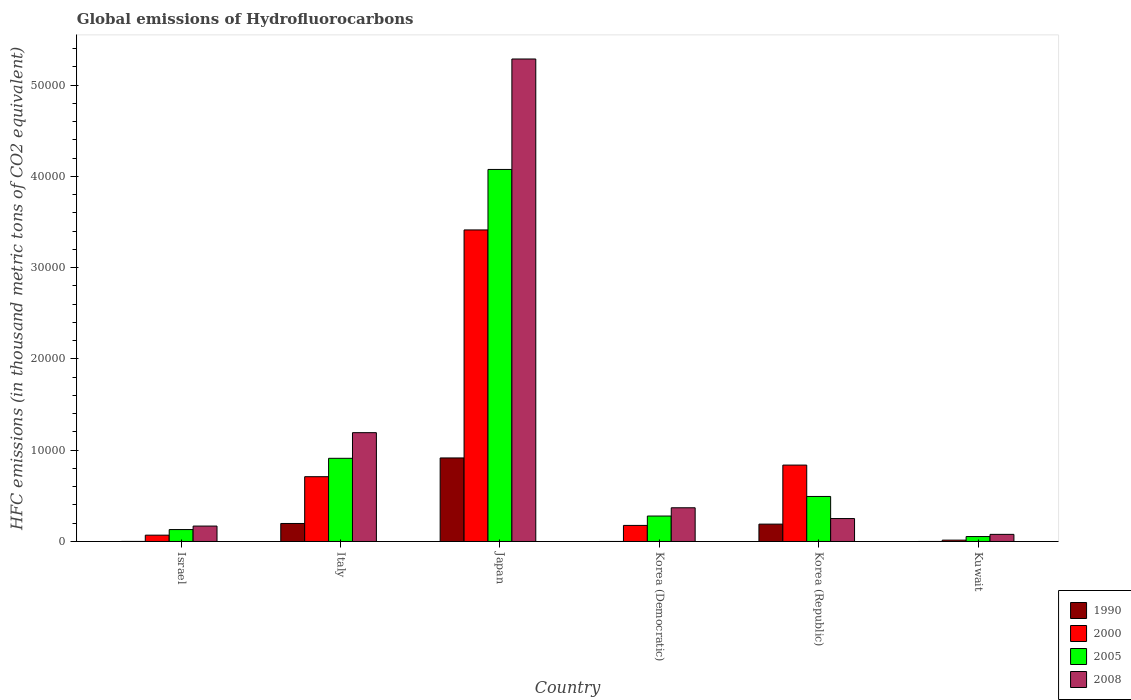Are the number of bars per tick equal to the number of legend labels?
Keep it short and to the point. Yes. How many bars are there on the 2nd tick from the left?
Make the answer very short. 4. In how many cases, is the number of bars for a given country not equal to the number of legend labels?
Make the answer very short. 0. What is the global emissions of Hydrofluorocarbons in 2000 in Japan?
Make the answer very short. 3.41e+04. Across all countries, what is the maximum global emissions of Hydrofluorocarbons in 1990?
Offer a terse response. 9154.3. Across all countries, what is the minimum global emissions of Hydrofluorocarbons in 2000?
Ensure brevity in your answer.  147.3. In which country was the global emissions of Hydrofluorocarbons in 2000 maximum?
Your answer should be compact. Japan. In which country was the global emissions of Hydrofluorocarbons in 2000 minimum?
Ensure brevity in your answer.  Kuwait. What is the total global emissions of Hydrofluorocarbons in 1990 in the graph?
Offer a very short reply. 1.30e+04. What is the difference between the global emissions of Hydrofluorocarbons in 2005 in Israel and that in Italy?
Keep it short and to the point. -7809.5. What is the difference between the global emissions of Hydrofluorocarbons in 1990 in Japan and the global emissions of Hydrofluorocarbons in 2008 in Italy?
Your response must be concise. -2770.2. What is the average global emissions of Hydrofluorocarbons in 2008 per country?
Provide a succinct answer. 1.22e+04. What is the difference between the global emissions of Hydrofluorocarbons of/in 2000 and global emissions of Hydrofluorocarbons of/in 2005 in Italy?
Offer a very short reply. -2015. In how many countries, is the global emissions of Hydrofluorocarbons in 1990 greater than 10000 thousand metric tons?
Make the answer very short. 0. What is the ratio of the global emissions of Hydrofluorocarbons in 1990 in Israel to that in Italy?
Keep it short and to the point. 0. What is the difference between the highest and the second highest global emissions of Hydrofluorocarbons in 2005?
Provide a short and direct response. 3.17e+04. What is the difference between the highest and the lowest global emissions of Hydrofluorocarbons in 2000?
Ensure brevity in your answer.  3.40e+04. In how many countries, is the global emissions of Hydrofluorocarbons in 2000 greater than the average global emissions of Hydrofluorocarbons in 2000 taken over all countries?
Give a very brief answer. 1. Is it the case that in every country, the sum of the global emissions of Hydrofluorocarbons in 2005 and global emissions of Hydrofluorocarbons in 1990 is greater than the sum of global emissions of Hydrofluorocarbons in 2008 and global emissions of Hydrofluorocarbons in 2000?
Ensure brevity in your answer.  No. How many bars are there?
Offer a terse response. 24. Are all the bars in the graph horizontal?
Offer a very short reply. No. How many countries are there in the graph?
Give a very brief answer. 6. What is the difference between two consecutive major ticks on the Y-axis?
Your response must be concise. 10000. Are the values on the major ticks of Y-axis written in scientific E-notation?
Give a very brief answer. No. Does the graph contain any zero values?
Your response must be concise. No. Where does the legend appear in the graph?
Your answer should be very brief. Bottom right. How are the legend labels stacked?
Keep it short and to the point. Vertical. What is the title of the graph?
Ensure brevity in your answer.  Global emissions of Hydrofluorocarbons. Does "1994" appear as one of the legend labels in the graph?
Offer a very short reply. No. What is the label or title of the Y-axis?
Provide a succinct answer. HFC emissions (in thousand metric tons of CO2 equivalent). What is the HFC emissions (in thousand metric tons of CO2 equivalent) of 2000 in Israel?
Your answer should be compact. 691.9. What is the HFC emissions (in thousand metric tons of CO2 equivalent) in 2005 in Israel?
Give a very brief answer. 1305. What is the HFC emissions (in thousand metric tons of CO2 equivalent) of 2008 in Israel?
Your response must be concise. 1687.8. What is the HFC emissions (in thousand metric tons of CO2 equivalent) in 1990 in Italy?
Offer a very short reply. 1972.2. What is the HFC emissions (in thousand metric tons of CO2 equivalent) of 2000 in Italy?
Your answer should be very brief. 7099.5. What is the HFC emissions (in thousand metric tons of CO2 equivalent) of 2005 in Italy?
Your answer should be very brief. 9114.5. What is the HFC emissions (in thousand metric tons of CO2 equivalent) of 2008 in Italy?
Provide a succinct answer. 1.19e+04. What is the HFC emissions (in thousand metric tons of CO2 equivalent) of 1990 in Japan?
Give a very brief answer. 9154.3. What is the HFC emissions (in thousand metric tons of CO2 equivalent) of 2000 in Japan?
Your answer should be compact. 3.41e+04. What is the HFC emissions (in thousand metric tons of CO2 equivalent) in 2005 in Japan?
Your answer should be very brief. 4.08e+04. What is the HFC emissions (in thousand metric tons of CO2 equivalent) of 2008 in Japan?
Give a very brief answer. 5.29e+04. What is the HFC emissions (in thousand metric tons of CO2 equivalent) in 2000 in Korea (Democratic)?
Offer a very short reply. 1760.1. What is the HFC emissions (in thousand metric tons of CO2 equivalent) in 2005 in Korea (Democratic)?
Provide a succinct answer. 2787.1. What is the HFC emissions (in thousand metric tons of CO2 equivalent) in 2008 in Korea (Democratic)?
Your response must be concise. 3693.8. What is the HFC emissions (in thousand metric tons of CO2 equivalent) of 1990 in Korea (Republic)?
Keep it short and to the point. 1901.7. What is the HFC emissions (in thousand metric tons of CO2 equivalent) in 2000 in Korea (Republic)?
Keep it short and to the point. 8371.9. What is the HFC emissions (in thousand metric tons of CO2 equivalent) in 2005 in Korea (Republic)?
Keep it short and to the point. 4933.9. What is the HFC emissions (in thousand metric tons of CO2 equivalent) in 2008 in Korea (Republic)?
Offer a terse response. 2511.2. What is the HFC emissions (in thousand metric tons of CO2 equivalent) of 2000 in Kuwait?
Provide a short and direct response. 147.3. What is the HFC emissions (in thousand metric tons of CO2 equivalent) of 2005 in Kuwait?
Offer a very short reply. 539.6. What is the HFC emissions (in thousand metric tons of CO2 equivalent) of 2008 in Kuwait?
Your response must be concise. 779. Across all countries, what is the maximum HFC emissions (in thousand metric tons of CO2 equivalent) in 1990?
Provide a short and direct response. 9154.3. Across all countries, what is the maximum HFC emissions (in thousand metric tons of CO2 equivalent) of 2000?
Your answer should be compact. 3.41e+04. Across all countries, what is the maximum HFC emissions (in thousand metric tons of CO2 equivalent) of 2005?
Provide a short and direct response. 4.08e+04. Across all countries, what is the maximum HFC emissions (in thousand metric tons of CO2 equivalent) in 2008?
Keep it short and to the point. 5.29e+04. Across all countries, what is the minimum HFC emissions (in thousand metric tons of CO2 equivalent) of 1990?
Provide a succinct answer. 0.1. Across all countries, what is the minimum HFC emissions (in thousand metric tons of CO2 equivalent) of 2000?
Offer a terse response. 147.3. Across all countries, what is the minimum HFC emissions (in thousand metric tons of CO2 equivalent) of 2005?
Make the answer very short. 539.6. Across all countries, what is the minimum HFC emissions (in thousand metric tons of CO2 equivalent) in 2008?
Offer a very short reply. 779. What is the total HFC emissions (in thousand metric tons of CO2 equivalent) in 1990 in the graph?
Provide a succinct answer. 1.30e+04. What is the total HFC emissions (in thousand metric tons of CO2 equivalent) in 2000 in the graph?
Offer a terse response. 5.22e+04. What is the total HFC emissions (in thousand metric tons of CO2 equivalent) in 2005 in the graph?
Your answer should be compact. 5.94e+04. What is the total HFC emissions (in thousand metric tons of CO2 equivalent) in 2008 in the graph?
Your answer should be very brief. 7.35e+04. What is the difference between the HFC emissions (in thousand metric tons of CO2 equivalent) of 1990 in Israel and that in Italy?
Offer a very short reply. -1967.6. What is the difference between the HFC emissions (in thousand metric tons of CO2 equivalent) in 2000 in Israel and that in Italy?
Make the answer very short. -6407.6. What is the difference between the HFC emissions (in thousand metric tons of CO2 equivalent) in 2005 in Israel and that in Italy?
Your answer should be compact. -7809.5. What is the difference between the HFC emissions (in thousand metric tons of CO2 equivalent) in 2008 in Israel and that in Italy?
Your answer should be very brief. -1.02e+04. What is the difference between the HFC emissions (in thousand metric tons of CO2 equivalent) in 1990 in Israel and that in Japan?
Keep it short and to the point. -9149.7. What is the difference between the HFC emissions (in thousand metric tons of CO2 equivalent) of 2000 in Israel and that in Japan?
Provide a succinct answer. -3.34e+04. What is the difference between the HFC emissions (in thousand metric tons of CO2 equivalent) of 2005 in Israel and that in Japan?
Keep it short and to the point. -3.95e+04. What is the difference between the HFC emissions (in thousand metric tons of CO2 equivalent) in 2008 in Israel and that in Japan?
Make the answer very short. -5.12e+04. What is the difference between the HFC emissions (in thousand metric tons of CO2 equivalent) of 2000 in Israel and that in Korea (Democratic)?
Ensure brevity in your answer.  -1068.2. What is the difference between the HFC emissions (in thousand metric tons of CO2 equivalent) of 2005 in Israel and that in Korea (Democratic)?
Your answer should be compact. -1482.1. What is the difference between the HFC emissions (in thousand metric tons of CO2 equivalent) in 2008 in Israel and that in Korea (Democratic)?
Your answer should be very brief. -2006. What is the difference between the HFC emissions (in thousand metric tons of CO2 equivalent) in 1990 in Israel and that in Korea (Republic)?
Keep it short and to the point. -1897.1. What is the difference between the HFC emissions (in thousand metric tons of CO2 equivalent) of 2000 in Israel and that in Korea (Republic)?
Provide a succinct answer. -7680. What is the difference between the HFC emissions (in thousand metric tons of CO2 equivalent) of 2005 in Israel and that in Korea (Republic)?
Keep it short and to the point. -3628.9. What is the difference between the HFC emissions (in thousand metric tons of CO2 equivalent) in 2008 in Israel and that in Korea (Republic)?
Your response must be concise. -823.4. What is the difference between the HFC emissions (in thousand metric tons of CO2 equivalent) in 1990 in Israel and that in Kuwait?
Provide a short and direct response. 4.5. What is the difference between the HFC emissions (in thousand metric tons of CO2 equivalent) of 2000 in Israel and that in Kuwait?
Make the answer very short. 544.6. What is the difference between the HFC emissions (in thousand metric tons of CO2 equivalent) in 2005 in Israel and that in Kuwait?
Keep it short and to the point. 765.4. What is the difference between the HFC emissions (in thousand metric tons of CO2 equivalent) in 2008 in Israel and that in Kuwait?
Your answer should be compact. 908.8. What is the difference between the HFC emissions (in thousand metric tons of CO2 equivalent) of 1990 in Italy and that in Japan?
Give a very brief answer. -7182.1. What is the difference between the HFC emissions (in thousand metric tons of CO2 equivalent) of 2000 in Italy and that in Japan?
Give a very brief answer. -2.70e+04. What is the difference between the HFC emissions (in thousand metric tons of CO2 equivalent) of 2005 in Italy and that in Japan?
Make the answer very short. -3.17e+04. What is the difference between the HFC emissions (in thousand metric tons of CO2 equivalent) of 2008 in Italy and that in Japan?
Offer a terse response. -4.09e+04. What is the difference between the HFC emissions (in thousand metric tons of CO2 equivalent) in 1990 in Italy and that in Korea (Democratic)?
Offer a very short reply. 1972. What is the difference between the HFC emissions (in thousand metric tons of CO2 equivalent) in 2000 in Italy and that in Korea (Democratic)?
Offer a very short reply. 5339.4. What is the difference between the HFC emissions (in thousand metric tons of CO2 equivalent) of 2005 in Italy and that in Korea (Democratic)?
Offer a terse response. 6327.4. What is the difference between the HFC emissions (in thousand metric tons of CO2 equivalent) of 2008 in Italy and that in Korea (Democratic)?
Your response must be concise. 8230.7. What is the difference between the HFC emissions (in thousand metric tons of CO2 equivalent) of 1990 in Italy and that in Korea (Republic)?
Make the answer very short. 70.5. What is the difference between the HFC emissions (in thousand metric tons of CO2 equivalent) in 2000 in Italy and that in Korea (Republic)?
Offer a very short reply. -1272.4. What is the difference between the HFC emissions (in thousand metric tons of CO2 equivalent) in 2005 in Italy and that in Korea (Republic)?
Ensure brevity in your answer.  4180.6. What is the difference between the HFC emissions (in thousand metric tons of CO2 equivalent) of 2008 in Italy and that in Korea (Republic)?
Provide a succinct answer. 9413.3. What is the difference between the HFC emissions (in thousand metric tons of CO2 equivalent) of 1990 in Italy and that in Kuwait?
Your answer should be compact. 1972.1. What is the difference between the HFC emissions (in thousand metric tons of CO2 equivalent) of 2000 in Italy and that in Kuwait?
Offer a very short reply. 6952.2. What is the difference between the HFC emissions (in thousand metric tons of CO2 equivalent) in 2005 in Italy and that in Kuwait?
Offer a very short reply. 8574.9. What is the difference between the HFC emissions (in thousand metric tons of CO2 equivalent) in 2008 in Italy and that in Kuwait?
Offer a very short reply. 1.11e+04. What is the difference between the HFC emissions (in thousand metric tons of CO2 equivalent) of 1990 in Japan and that in Korea (Democratic)?
Ensure brevity in your answer.  9154.1. What is the difference between the HFC emissions (in thousand metric tons of CO2 equivalent) of 2000 in Japan and that in Korea (Democratic)?
Provide a short and direct response. 3.24e+04. What is the difference between the HFC emissions (in thousand metric tons of CO2 equivalent) in 2005 in Japan and that in Korea (Democratic)?
Ensure brevity in your answer.  3.80e+04. What is the difference between the HFC emissions (in thousand metric tons of CO2 equivalent) in 2008 in Japan and that in Korea (Democratic)?
Make the answer very short. 4.92e+04. What is the difference between the HFC emissions (in thousand metric tons of CO2 equivalent) in 1990 in Japan and that in Korea (Republic)?
Offer a terse response. 7252.6. What is the difference between the HFC emissions (in thousand metric tons of CO2 equivalent) in 2000 in Japan and that in Korea (Republic)?
Make the answer very short. 2.58e+04. What is the difference between the HFC emissions (in thousand metric tons of CO2 equivalent) in 2005 in Japan and that in Korea (Republic)?
Your answer should be very brief. 3.58e+04. What is the difference between the HFC emissions (in thousand metric tons of CO2 equivalent) of 2008 in Japan and that in Korea (Republic)?
Give a very brief answer. 5.04e+04. What is the difference between the HFC emissions (in thousand metric tons of CO2 equivalent) of 1990 in Japan and that in Kuwait?
Offer a very short reply. 9154.2. What is the difference between the HFC emissions (in thousand metric tons of CO2 equivalent) in 2000 in Japan and that in Kuwait?
Make the answer very short. 3.40e+04. What is the difference between the HFC emissions (in thousand metric tons of CO2 equivalent) of 2005 in Japan and that in Kuwait?
Ensure brevity in your answer.  4.02e+04. What is the difference between the HFC emissions (in thousand metric tons of CO2 equivalent) in 2008 in Japan and that in Kuwait?
Keep it short and to the point. 5.21e+04. What is the difference between the HFC emissions (in thousand metric tons of CO2 equivalent) of 1990 in Korea (Democratic) and that in Korea (Republic)?
Give a very brief answer. -1901.5. What is the difference between the HFC emissions (in thousand metric tons of CO2 equivalent) of 2000 in Korea (Democratic) and that in Korea (Republic)?
Offer a very short reply. -6611.8. What is the difference between the HFC emissions (in thousand metric tons of CO2 equivalent) of 2005 in Korea (Democratic) and that in Korea (Republic)?
Your answer should be very brief. -2146.8. What is the difference between the HFC emissions (in thousand metric tons of CO2 equivalent) of 2008 in Korea (Democratic) and that in Korea (Republic)?
Your answer should be compact. 1182.6. What is the difference between the HFC emissions (in thousand metric tons of CO2 equivalent) of 2000 in Korea (Democratic) and that in Kuwait?
Your answer should be compact. 1612.8. What is the difference between the HFC emissions (in thousand metric tons of CO2 equivalent) in 2005 in Korea (Democratic) and that in Kuwait?
Your answer should be very brief. 2247.5. What is the difference between the HFC emissions (in thousand metric tons of CO2 equivalent) in 2008 in Korea (Democratic) and that in Kuwait?
Offer a terse response. 2914.8. What is the difference between the HFC emissions (in thousand metric tons of CO2 equivalent) of 1990 in Korea (Republic) and that in Kuwait?
Give a very brief answer. 1901.6. What is the difference between the HFC emissions (in thousand metric tons of CO2 equivalent) in 2000 in Korea (Republic) and that in Kuwait?
Keep it short and to the point. 8224.6. What is the difference between the HFC emissions (in thousand metric tons of CO2 equivalent) in 2005 in Korea (Republic) and that in Kuwait?
Give a very brief answer. 4394.3. What is the difference between the HFC emissions (in thousand metric tons of CO2 equivalent) in 2008 in Korea (Republic) and that in Kuwait?
Your answer should be compact. 1732.2. What is the difference between the HFC emissions (in thousand metric tons of CO2 equivalent) in 1990 in Israel and the HFC emissions (in thousand metric tons of CO2 equivalent) in 2000 in Italy?
Your answer should be compact. -7094.9. What is the difference between the HFC emissions (in thousand metric tons of CO2 equivalent) of 1990 in Israel and the HFC emissions (in thousand metric tons of CO2 equivalent) of 2005 in Italy?
Your response must be concise. -9109.9. What is the difference between the HFC emissions (in thousand metric tons of CO2 equivalent) of 1990 in Israel and the HFC emissions (in thousand metric tons of CO2 equivalent) of 2008 in Italy?
Keep it short and to the point. -1.19e+04. What is the difference between the HFC emissions (in thousand metric tons of CO2 equivalent) of 2000 in Israel and the HFC emissions (in thousand metric tons of CO2 equivalent) of 2005 in Italy?
Give a very brief answer. -8422.6. What is the difference between the HFC emissions (in thousand metric tons of CO2 equivalent) of 2000 in Israel and the HFC emissions (in thousand metric tons of CO2 equivalent) of 2008 in Italy?
Provide a short and direct response. -1.12e+04. What is the difference between the HFC emissions (in thousand metric tons of CO2 equivalent) in 2005 in Israel and the HFC emissions (in thousand metric tons of CO2 equivalent) in 2008 in Italy?
Offer a terse response. -1.06e+04. What is the difference between the HFC emissions (in thousand metric tons of CO2 equivalent) of 1990 in Israel and the HFC emissions (in thousand metric tons of CO2 equivalent) of 2000 in Japan?
Keep it short and to the point. -3.41e+04. What is the difference between the HFC emissions (in thousand metric tons of CO2 equivalent) of 1990 in Israel and the HFC emissions (in thousand metric tons of CO2 equivalent) of 2005 in Japan?
Provide a short and direct response. -4.08e+04. What is the difference between the HFC emissions (in thousand metric tons of CO2 equivalent) of 1990 in Israel and the HFC emissions (in thousand metric tons of CO2 equivalent) of 2008 in Japan?
Your response must be concise. -5.29e+04. What is the difference between the HFC emissions (in thousand metric tons of CO2 equivalent) of 2000 in Israel and the HFC emissions (in thousand metric tons of CO2 equivalent) of 2005 in Japan?
Give a very brief answer. -4.01e+04. What is the difference between the HFC emissions (in thousand metric tons of CO2 equivalent) of 2000 in Israel and the HFC emissions (in thousand metric tons of CO2 equivalent) of 2008 in Japan?
Your response must be concise. -5.22e+04. What is the difference between the HFC emissions (in thousand metric tons of CO2 equivalent) of 2005 in Israel and the HFC emissions (in thousand metric tons of CO2 equivalent) of 2008 in Japan?
Make the answer very short. -5.16e+04. What is the difference between the HFC emissions (in thousand metric tons of CO2 equivalent) of 1990 in Israel and the HFC emissions (in thousand metric tons of CO2 equivalent) of 2000 in Korea (Democratic)?
Give a very brief answer. -1755.5. What is the difference between the HFC emissions (in thousand metric tons of CO2 equivalent) of 1990 in Israel and the HFC emissions (in thousand metric tons of CO2 equivalent) of 2005 in Korea (Democratic)?
Keep it short and to the point. -2782.5. What is the difference between the HFC emissions (in thousand metric tons of CO2 equivalent) of 1990 in Israel and the HFC emissions (in thousand metric tons of CO2 equivalent) of 2008 in Korea (Democratic)?
Offer a terse response. -3689.2. What is the difference between the HFC emissions (in thousand metric tons of CO2 equivalent) of 2000 in Israel and the HFC emissions (in thousand metric tons of CO2 equivalent) of 2005 in Korea (Democratic)?
Give a very brief answer. -2095.2. What is the difference between the HFC emissions (in thousand metric tons of CO2 equivalent) of 2000 in Israel and the HFC emissions (in thousand metric tons of CO2 equivalent) of 2008 in Korea (Democratic)?
Your response must be concise. -3001.9. What is the difference between the HFC emissions (in thousand metric tons of CO2 equivalent) of 2005 in Israel and the HFC emissions (in thousand metric tons of CO2 equivalent) of 2008 in Korea (Democratic)?
Keep it short and to the point. -2388.8. What is the difference between the HFC emissions (in thousand metric tons of CO2 equivalent) of 1990 in Israel and the HFC emissions (in thousand metric tons of CO2 equivalent) of 2000 in Korea (Republic)?
Offer a terse response. -8367.3. What is the difference between the HFC emissions (in thousand metric tons of CO2 equivalent) in 1990 in Israel and the HFC emissions (in thousand metric tons of CO2 equivalent) in 2005 in Korea (Republic)?
Make the answer very short. -4929.3. What is the difference between the HFC emissions (in thousand metric tons of CO2 equivalent) in 1990 in Israel and the HFC emissions (in thousand metric tons of CO2 equivalent) in 2008 in Korea (Republic)?
Provide a short and direct response. -2506.6. What is the difference between the HFC emissions (in thousand metric tons of CO2 equivalent) of 2000 in Israel and the HFC emissions (in thousand metric tons of CO2 equivalent) of 2005 in Korea (Republic)?
Your response must be concise. -4242. What is the difference between the HFC emissions (in thousand metric tons of CO2 equivalent) of 2000 in Israel and the HFC emissions (in thousand metric tons of CO2 equivalent) of 2008 in Korea (Republic)?
Provide a short and direct response. -1819.3. What is the difference between the HFC emissions (in thousand metric tons of CO2 equivalent) of 2005 in Israel and the HFC emissions (in thousand metric tons of CO2 equivalent) of 2008 in Korea (Republic)?
Provide a succinct answer. -1206.2. What is the difference between the HFC emissions (in thousand metric tons of CO2 equivalent) of 1990 in Israel and the HFC emissions (in thousand metric tons of CO2 equivalent) of 2000 in Kuwait?
Ensure brevity in your answer.  -142.7. What is the difference between the HFC emissions (in thousand metric tons of CO2 equivalent) of 1990 in Israel and the HFC emissions (in thousand metric tons of CO2 equivalent) of 2005 in Kuwait?
Your answer should be very brief. -535. What is the difference between the HFC emissions (in thousand metric tons of CO2 equivalent) in 1990 in Israel and the HFC emissions (in thousand metric tons of CO2 equivalent) in 2008 in Kuwait?
Give a very brief answer. -774.4. What is the difference between the HFC emissions (in thousand metric tons of CO2 equivalent) of 2000 in Israel and the HFC emissions (in thousand metric tons of CO2 equivalent) of 2005 in Kuwait?
Offer a very short reply. 152.3. What is the difference between the HFC emissions (in thousand metric tons of CO2 equivalent) in 2000 in Israel and the HFC emissions (in thousand metric tons of CO2 equivalent) in 2008 in Kuwait?
Your answer should be compact. -87.1. What is the difference between the HFC emissions (in thousand metric tons of CO2 equivalent) in 2005 in Israel and the HFC emissions (in thousand metric tons of CO2 equivalent) in 2008 in Kuwait?
Ensure brevity in your answer.  526. What is the difference between the HFC emissions (in thousand metric tons of CO2 equivalent) of 1990 in Italy and the HFC emissions (in thousand metric tons of CO2 equivalent) of 2000 in Japan?
Ensure brevity in your answer.  -3.22e+04. What is the difference between the HFC emissions (in thousand metric tons of CO2 equivalent) of 1990 in Italy and the HFC emissions (in thousand metric tons of CO2 equivalent) of 2005 in Japan?
Provide a short and direct response. -3.88e+04. What is the difference between the HFC emissions (in thousand metric tons of CO2 equivalent) of 1990 in Italy and the HFC emissions (in thousand metric tons of CO2 equivalent) of 2008 in Japan?
Provide a succinct answer. -5.09e+04. What is the difference between the HFC emissions (in thousand metric tons of CO2 equivalent) in 2000 in Italy and the HFC emissions (in thousand metric tons of CO2 equivalent) in 2005 in Japan?
Keep it short and to the point. -3.37e+04. What is the difference between the HFC emissions (in thousand metric tons of CO2 equivalent) in 2000 in Italy and the HFC emissions (in thousand metric tons of CO2 equivalent) in 2008 in Japan?
Your answer should be very brief. -4.58e+04. What is the difference between the HFC emissions (in thousand metric tons of CO2 equivalent) in 2005 in Italy and the HFC emissions (in thousand metric tons of CO2 equivalent) in 2008 in Japan?
Provide a short and direct response. -4.38e+04. What is the difference between the HFC emissions (in thousand metric tons of CO2 equivalent) in 1990 in Italy and the HFC emissions (in thousand metric tons of CO2 equivalent) in 2000 in Korea (Democratic)?
Make the answer very short. 212.1. What is the difference between the HFC emissions (in thousand metric tons of CO2 equivalent) of 1990 in Italy and the HFC emissions (in thousand metric tons of CO2 equivalent) of 2005 in Korea (Democratic)?
Make the answer very short. -814.9. What is the difference between the HFC emissions (in thousand metric tons of CO2 equivalent) in 1990 in Italy and the HFC emissions (in thousand metric tons of CO2 equivalent) in 2008 in Korea (Democratic)?
Provide a short and direct response. -1721.6. What is the difference between the HFC emissions (in thousand metric tons of CO2 equivalent) of 2000 in Italy and the HFC emissions (in thousand metric tons of CO2 equivalent) of 2005 in Korea (Democratic)?
Your response must be concise. 4312.4. What is the difference between the HFC emissions (in thousand metric tons of CO2 equivalent) in 2000 in Italy and the HFC emissions (in thousand metric tons of CO2 equivalent) in 2008 in Korea (Democratic)?
Your response must be concise. 3405.7. What is the difference between the HFC emissions (in thousand metric tons of CO2 equivalent) in 2005 in Italy and the HFC emissions (in thousand metric tons of CO2 equivalent) in 2008 in Korea (Democratic)?
Offer a terse response. 5420.7. What is the difference between the HFC emissions (in thousand metric tons of CO2 equivalent) in 1990 in Italy and the HFC emissions (in thousand metric tons of CO2 equivalent) in 2000 in Korea (Republic)?
Your response must be concise. -6399.7. What is the difference between the HFC emissions (in thousand metric tons of CO2 equivalent) in 1990 in Italy and the HFC emissions (in thousand metric tons of CO2 equivalent) in 2005 in Korea (Republic)?
Ensure brevity in your answer.  -2961.7. What is the difference between the HFC emissions (in thousand metric tons of CO2 equivalent) in 1990 in Italy and the HFC emissions (in thousand metric tons of CO2 equivalent) in 2008 in Korea (Republic)?
Give a very brief answer. -539. What is the difference between the HFC emissions (in thousand metric tons of CO2 equivalent) of 2000 in Italy and the HFC emissions (in thousand metric tons of CO2 equivalent) of 2005 in Korea (Republic)?
Your answer should be very brief. 2165.6. What is the difference between the HFC emissions (in thousand metric tons of CO2 equivalent) in 2000 in Italy and the HFC emissions (in thousand metric tons of CO2 equivalent) in 2008 in Korea (Republic)?
Your answer should be very brief. 4588.3. What is the difference between the HFC emissions (in thousand metric tons of CO2 equivalent) of 2005 in Italy and the HFC emissions (in thousand metric tons of CO2 equivalent) of 2008 in Korea (Republic)?
Your answer should be very brief. 6603.3. What is the difference between the HFC emissions (in thousand metric tons of CO2 equivalent) in 1990 in Italy and the HFC emissions (in thousand metric tons of CO2 equivalent) in 2000 in Kuwait?
Provide a short and direct response. 1824.9. What is the difference between the HFC emissions (in thousand metric tons of CO2 equivalent) in 1990 in Italy and the HFC emissions (in thousand metric tons of CO2 equivalent) in 2005 in Kuwait?
Give a very brief answer. 1432.6. What is the difference between the HFC emissions (in thousand metric tons of CO2 equivalent) in 1990 in Italy and the HFC emissions (in thousand metric tons of CO2 equivalent) in 2008 in Kuwait?
Your answer should be very brief. 1193.2. What is the difference between the HFC emissions (in thousand metric tons of CO2 equivalent) in 2000 in Italy and the HFC emissions (in thousand metric tons of CO2 equivalent) in 2005 in Kuwait?
Provide a short and direct response. 6559.9. What is the difference between the HFC emissions (in thousand metric tons of CO2 equivalent) in 2000 in Italy and the HFC emissions (in thousand metric tons of CO2 equivalent) in 2008 in Kuwait?
Keep it short and to the point. 6320.5. What is the difference between the HFC emissions (in thousand metric tons of CO2 equivalent) in 2005 in Italy and the HFC emissions (in thousand metric tons of CO2 equivalent) in 2008 in Kuwait?
Your answer should be compact. 8335.5. What is the difference between the HFC emissions (in thousand metric tons of CO2 equivalent) of 1990 in Japan and the HFC emissions (in thousand metric tons of CO2 equivalent) of 2000 in Korea (Democratic)?
Offer a terse response. 7394.2. What is the difference between the HFC emissions (in thousand metric tons of CO2 equivalent) in 1990 in Japan and the HFC emissions (in thousand metric tons of CO2 equivalent) in 2005 in Korea (Democratic)?
Provide a short and direct response. 6367.2. What is the difference between the HFC emissions (in thousand metric tons of CO2 equivalent) in 1990 in Japan and the HFC emissions (in thousand metric tons of CO2 equivalent) in 2008 in Korea (Democratic)?
Ensure brevity in your answer.  5460.5. What is the difference between the HFC emissions (in thousand metric tons of CO2 equivalent) of 2000 in Japan and the HFC emissions (in thousand metric tons of CO2 equivalent) of 2005 in Korea (Democratic)?
Offer a very short reply. 3.14e+04. What is the difference between the HFC emissions (in thousand metric tons of CO2 equivalent) of 2000 in Japan and the HFC emissions (in thousand metric tons of CO2 equivalent) of 2008 in Korea (Democratic)?
Provide a short and direct response. 3.04e+04. What is the difference between the HFC emissions (in thousand metric tons of CO2 equivalent) in 2005 in Japan and the HFC emissions (in thousand metric tons of CO2 equivalent) in 2008 in Korea (Democratic)?
Offer a terse response. 3.71e+04. What is the difference between the HFC emissions (in thousand metric tons of CO2 equivalent) of 1990 in Japan and the HFC emissions (in thousand metric tons of CO2 equivalent) of 2000 in Korea (Republic)?
Provide a succinct answer. 782.4. What is the difference between the HFC emissions (in thousand metric tons of CO2 equivalent) of 1990 in Japan and the HFC emissions (in thousand metric tons of CO2 equivalent) of 2005 in Korea (Republic)?
Your answer should be very brief. 4220.4. What is the difference between the HFC emissions (in thousand metric tons of CO2 equivalent) of 1990 in Japan and the HFC emissions (in thousand metric tons of CO2 equivalent) of 2008 in Korea (Republic)?
Provide a short and direct response. 6643.1. What is the difference between the HFC emissions (in thousand metric tons of CO2 equivalent) of 2000 in Japan and the HFC emissions (in thousand metric tons of CO2 equivalent) of 2005 in Korea (Republic)?
Provide a succinct answer. 2.92e+04. What is the difference between the HFC emissions (in thousand metric tons of CO2 equivalent) of 2000 in Japan and the HFC emissions (in thousand metric tons of CO2 equivalent) of 2008 in Korea (Republic)?
Your response must be concise. 3.16e+04. What is the difference between the HFC emissions (in thousand metric tons of CO2 equivalent) in 2005 in Japan and the HFC emissions (in thousand metric tons of CO2 equivalent) in 2008 in Korea (Republic)?
Offer a very short reply. 3.83e+04. What is the difference between the HFC emissions (in thousand metric tons of CO2 equivalent) in 1990 in Japan and the HFC emissions (in thousand metric tons of CO2 equivalent) in 2000 in Kuwait?
Make the answer very short. 9007. What is the difference between the HFC emissions (in thousand metric tons of CO2 equivalent) of 1990 in Japan and the HFC emissions (in thousand metric tons of CO2 equivalent) of 2005 in Kuwait?
Offer a very short reply. 8614.7. What is the difference between the HFC emissions (in thousand metric tons of CO2 equivalent) in 1990 in Japan and the HFC emissions (in thousand metric tons of CO2 equivalent) in 2008 in Kuwait?
Your response must be concise. 8375.3. What is the difference between the HFC emissions (in thousand metric tons of CO2 equivalent) in 2000 in Japan and the HFC emissions (in thousand metric tons of CO2 equivalent) in 2005 in Kuwait?
Offer a very short reply. 3.36e+04. What is the difference between the HFC emissions (in thousand metric tons of CO2 equivalent) in 2000 in Japan and the HFC emissions (in thousand metric tons of CO2 equivalent) in 2008 in Kuwait?
Provide a succinct answer. 3.34e+04. What is the difference between the HFC emissions (in thousand metric tons of CO2 equivalent) of 2005 in Japan and the HFC emissions (in thousand metric tons of CO2 equivalent) of 2008 in Kuwait?
Keep it short and to the point. 4.00e+04. What is the difference between the HFC emissions (in thousand metric tons of CO2 equivalent) in 1990 in Korea (Democratic) and the HFC emissions (in thousand metric tons of CO2 equivalent) in 2000 in Korea (Republic)?
Your answer should be very brief. -8371.7. What is the difference between the HFC emissions (in thousand metric tons of CO2 equivalent) in 1990 in Korea (Democratic) and the HFC emissions (in thousand metric tons of CO2 equivalent) in 2005 in Korea (Republic)?
Provide a succinct answer. -4933.7. What is the difference between the HFC emissions (in thousand metric tons of CO2 equivalent) of 1990 in Korea (Democratic) and the HFC emissions (in thousand metric tons of CO2 equivalent) of 2008 in Korea (Republic)?
Offer a terse response. -2511. What is the difference between the HFC emissions (in thousand metric tons of CO2 equivalent) in 2000 in Korea (Democratic) and the HFC emissions (in thousand metric tons of CO2 equivalent) in 2005 in Korea (Republic)?
Give a very brief answer. -3173.8. What is the difference between the HFC emissions (in thousand metric tons of CO2 equivalent) of 2000 in Korea (Democratic) and the HFC emissions (in thousand metric tons of CO2 equivalent) of 2008 in Korea (Republic)?
Your answer should be very brief. -751.1. What is the difference between the HFC emissions (in thousand metric tons of CO2 equivalent) in 2005 in Korea (Democratic) and the HFC emissions (in thousand metric tons of CO2 equivalent) in 2008 in Korea (Republic)?
Your response must be concise. 275.9. What is the difference between the HFC emissions (in thousand metric tons of CO2 equivalent) in 1990 in Korea (Democratic) and the HFC emissions (in thousand metric tons of CO2 equivalent) in 2000 in Kuwait?
Your response must be concise. -147.1. What is the difference between the HFC emissions (in thousand metric tons of CO2 equivalent) in 1990 in Korea (Democratic) and the HFC emissions (in thousand metric tons of CO2 equivalent) in 2005 in Kuwait?
Your answer should be very brief. -539.4. What is the difference between the HFC emissions (in thousand metric tons of CO2 equivalent) of 1990 in Korea (Democratic) and the HFC emissions (in thousand metric tons of CO2 equivalent) of 2008 in Kuwait?
Your answer should be very brief. -778.8. What is the difference between the HFC emissions (in thousand metric tons of CO2 equivalent) of 2000 in Korea (Democratic) and the HFC emissions (in thousand metric tons of CO2 equivalent) of 2005 in Kuwait?
Provide a succinct answer. 1220.5. What is the difference between the HFC emissions (in thousand metric tons of CO2 equivalent) of 2000 in Korea (Democratic) and the HFC emissions (in thousand metric tons of CO2 equivalent) of 2008 in Kuwait?
Give a very brief answer. 981.1. What is the difference between the HFC emissions (in thousand metric tons of CO2 equivalent) in 2005 in Korea (Democratic) and the HFC emissions (in thousand metric tons of CO2 equivalent) in 2008 in Kuwait?
Ensure brevity in your answer.  2008.1. What is the difference between the HFC emissions (in thousand metric tons of CO2 equivalent) in 1990 in Korea (Republic) and the HFC emissions (in thousand metric tons of CO2 equivalent) in 2000 in Kuwait?
Give a very brief answer. 1754.4. What is the difference between the HFC emissions (in thousand metric tons of CO2 equivalent) of 1990 in Korea (Republic) and the HFC emissions (in thousand metric tons of CO2 equivalent) of 2005 in Kuwait?
Provide a short and direct response. 1362.1. What is the difference between the HFC emissions (in thousand metric tons of CO2 equivalent) in 1990 in Korea (Republic) and the HFC emissions (in thousand metric tons of CO2 equivalent) in 2008 in Kuwait?
Ensure brevity in your answer.  1122.7. What is the difference between the HFC emissions (in thousand metric tons of CO2 equivalent) of 2000 in Korea (Republic) and the HFC emissions (in thousand metric tons of CO2 equivalent) of 2005 in Kuwait?
Your answer should be compact. 7832.3. What is the difference between the HFC emissions (in thousand metric tons of CO2 equivalent) in 2000 in Korea (Republic) and the HFC emissions (in thousand metric tons of CO2 equivalent) in 2008 in Kuwait?
Your response must be concise. 7592.9. What is the difference between the HFC emissions (in thousand metric tons of CO2 equivalent) of 2005 in Korea (Republic) and the HFC emissions (in thousand metric tons of CO2 equivalent) of 2008 in Kuwait?
Provide a short and direct response. 4154.9. What is the average HFC emissions (in thousand metric tons of CO2 equivalent) in 1990 per country?
Offer a terse response. 2172.18. What is the average HFC emissions (in thousand metric tons of CO2 equivalent) of 2000 per country?
Ensure brevity in your answer.  8701.75. What is the average HFC emissions (in thousand metric tons of CO2 equivalent) in 2005 per country?
Offer a very short reply. 9908.1. What is the average HFC emissions (in thousand metric tons of CO2 equivalent) in 2008 per country?
Provide a succinct answer. 1.22e+04. What is the difference between the HFC emissions (in thousand metric tons of CO2 equivalent) in 1990 and HFC emissions (in thousand metric tons of CO2 equivalent) in 2000 in Israel?
Offer a terse response. -687.3. What is the difference between the HFC emissions (in thousand metric tons of CO2 equivalent) of 1990 and HFC emissions (in thousand metric tons of CO2 equivalent) of 2005 in Israel?
Your answer should be compact. -1300.4. What is the difference between the HFC emissions (in thousand metric tons of CO2 equivalent) in 1990 and HFC emissions (in thousand metric tons of CO2 equivalent) in 2008 in Israel?
Your response must be concise. -1683.2. What is the difference between the HFC emissions (in thousand metric tons of CO2 equivalent) of 2000 and HFC emissions (in thousand metric tons of CO2 equivalent) of 2005 in Israel?
Your response must be concise. -613.1. What is the difference between the HFC emissions (in thousand metric tons of CO2 equivalent) in 2000 and HFC emissions (in thousand metric tons of CO2 equivalent) in 2008 in Israel?
Give a very brief answer. -995.9. What is the difference between the HFC emissions (in thousand metric tons of CO2 equivalent) of 2005 and HFC emissions (in thousand metric tons of CO2 equivalent) of 2008 in Israel?
Make the answer very short. -382.8. What is the difference between the HFC emissions (in thousand metric tons of CO2 equivalent) of 1990 and HFC emissions (in thousand metric tons of CO2 equivalent) of 2000 in Italy?
Ensure brevity in your answer.  -5127.3. What is the difference between the HFC emissions (in thousand metric tons of CO2 equivalent) of 1990 and HFC emissions (in thousand metric tons of CO2 equivalent) of 2005 in Italy?
Provide a succinct answer. -7142.3. What is the difference between the HFC emissions (in thousand metric tons of CO2 equivalent) in 1990 and HFC emissions (in thousand metric tons of CO2 equivalent) in 2008 in Italy?
Your answer should be compact. -9952.3. What is the difference between the HFC emissions (in thousand metric tons of CO2 equivalent) in 2000 and HFC emissions (in thousand metric tons of CO2 equivalent) in 2005 in Italy?
Keep it short and to the point. -2015. What is the difference between the HFC emissions (in thousand metric tons of CO2 equivalent) in 2000 and HFC emissions (in thousand metric tons of CO2 equivalent) in 2008 in Italy?
Ensure brevity in your answer.  -4825. What is the difference between the HFC emissions (in thousand metric tons of CO2 equivalent) of 2005 and HFC emissions (in thousand metric tons of CO2 equivalent) of 2008 in Italy?
Your answer should be very brief. -2810. What is the difference between the HFC emissions (in thousand metric tons of CO2 equivalent) in 1990 and HFC emissions (in thousand metric tons of CO2 equivalent) in 2000 in Japan?
Provide a short and direct response. -2.50e+04. What is the difference between the HFC emissions (in thousand metric tons of CO2 equivalent) in 1990 and HFC emissions (in thousand metric tons of CO2 equivalent) in 2005 in Japan?
Keep it short and to the point. -3.16e+04. What is the difference between the HFC emissions (in thousand metric tons of CO2 equivalent) in 1990 and HFC emissions (in thousand metric tons of CO2 equivalent) in 2008 in Japan?
Give a very brief answer. -4.37e+04. What is the difference between the HFC emissions (in thousand metric tons of CO2 equivalent) of 2000 and HFC emissions (in thousand metric tons of CO2 equivalent) of 2005 in Japan?
Your response must be concise. -6628.7. What is the difference between the HFC emissions (in thousand metric tons of CO2 equivalent) in 2000 and HFC emissions (in thousand metric tons of CO2 equivalent) in 2008 in Japan?
Provide a short and direct response. -1.87e+04. What is the difference between the HFC emissions (in thousand metric tons of CO2 equivalent) in 2005 and HFC emissions (in thousand metric tons of CO2 equivalent) in 2008 in Japan?
Offer a terse response. -1.21e+04. What is the difference between the HFC emissions (in thousand metric tons of CO2 equivalent) of 1990 and HFC emissions (in thousand metric tons of CO2 equivalent) of 2000 in Korea (Democratic)?
Your answer should be very brief. -1759.9. What is the difference between the HFC emissions (in thousand metric tons of CO2 equivalent) of 1990 and HFC emissions (in thousand metric tons of CO2 equivalent) of 2005 in Korea (Democratic)?
Keep it short and to the point. -2786.9. What is the difference between the HFC emissions (in thousand metric tons of CO2 equivalent) in 1990 and HFC emissions (in thousand metric tons of CO2 equivalent) in 2008 in Korea (Democratic)?
Your response must be concise. -3693.6. What is the difference between the HFC emissions (in thousand metric tons of CO2 equivalent) in 2000 and HFC emissions (in thousand metric tons of CO2 equivalent) in 2005 in Korea (Democratic)?
Keep it short and to the point. -1027. What is the difference between the HFC emissions (in thousand metric tons of CO2 equivalent) in 2000 and HFC emissions (in thousand metric tons of CO2 equivalent) in 2008 in Korea (Democratic)?
Offer a very short reply. -1933.7. What is the difference between the HFC emissions (in thousand metric tons of CO2 equivalent) in 2005 and HFC emissions (in thousand metric tons of CO2 equivalent) in 2008 in Korea (Democratic)?
Your response must be concise. -906.7. What is the difference between the HFC emissions (in thousand metric tons of CO2 equivalent) in 1990 and HFC emissions (in thousand metric tons of CO2 equivalent) in 2000 in Korea (Republic)?
Give a very brief answer. -6470.2. What is the difference between the HFC emissions (in thousand metric tons of CO2 equivalent) of 1990 and HFC emissions (in thousand metric tons of CO2 equivalent) of 2005 in Korea (Republic)?
Keep it short and to the point. -3032.2. What is the difference between the HFC emissions (in thousand metric tons of CO2 equivalent) of 1990 and HFC emissions (in thousand metric tons of CO2 equivalent) of 2008 in Korea (Republic)?
Your response must be concise. -609.5. What is the difference between the HFC emissions (in thousand metric tons of CO2 equivalent) of 2000 and HFC emissions (in thousand metric tons of CO2 equivalent) of 2005 in Korea (Republic)?
Your answer should be compact. 3438. What is the difference between the HFC emissions (in thousand metric tons of CO2 equivalent) in 2000 and HFC emissions (in thousand metric tons of CO2 equivalent) in 2008 in Korea (Republic)?
Give a very brief answer. 5860.7. What is the difference between the HFC emissions (in thousand metric tons of CO2 equivalent) of 2005 and HFC emissions (in thousand metric tons of CO2 equivalent) of 2008 in Korea (Republic)?
Your response must be concise. 2422.7. What is the difference between the HFC emissions (in thousand metric tons of CO2 equivalent) in 1990 and HFC emissions (in thousand metric tons of CO2 equivalent) in 2000 in Kuwait?
Ensure brevity in your answer.  -147.2. What is the difference between the HFC emissions (in thousand metric tons of CO2 equivalent) of 1990 and HFC emissions (in thousand metric tons of CO2 equivalent) of 2005 in Kuwait?
Provide a short and direct response. -539.5. What is the difference between the HFC emissions (in thousand metric tons of CO2 equivalent) in 1990 and HFC emissions (in thousand metric tons of CO2 equivalent) in 2008 in Kuwait?
Offer a terse response. -778.9. What is the difference between the HFC emissions (in thousand metric tons of CO2 equivalent) in 2000 and HFC emissions (in thousand metric tons of CO2 equivalent) in 2005 in Kuwait?
Your response must be concise. -392.3. What is the difference between the HFC emissions (in thousand metric tons of CO2 equivalent) in 2000 and HFC emissions (in thousand metric tons of CO2 equivalent) in 2008 in Kuwait?
Give a very brief answer. -631.7. What is the difference between the HFC emissions (in thousand metric tons of CO2 equivalent) of 2005 and HFC emissions (in thousand metric tons of CO2 equivalent) of 2008 in Kuwait?
Your response must be concise. -239.4. What is the ratio of the HFC emissions (in thousand metric tons of CO2 equivalent) in 1990 in Israel to that in Italy?
Keep it short and to the point. 0. What is the ratio of the HFC emissions (in thousand metric tons of CO2 equivalent) of 2000 in Israel to that in Italy?
Your response must be concise. 0.1. What is the ratio of the HFC emissions (in thousand metric tons of CO2 equivalent) in 2005 in Israel to that in Italy?
Provide a short and direct response. 0.14. What is the ratio of the HFC emissions (in thousand metric tons of CO2 equivalent) in 2008 in Israel to that in Italy?
Give a very brief answer. 0.14. What is the ratio of the HFC emissions (in thousand metric tons of CO2 equivalent) of 1990 in Israel to that in Japan?
Keep it short and to the point. 0. What is the ratio of the HFC emissions (in thousand metric tons of CO2 equivalent) in 2000 in Israel to that in Japan?
Give a very brief answer. 0.02. What is the ratio of the HFC emissions (in thousand metric tons of CO2 equivalent) in 2005 in Israel to that in Japan?
Your answer should be compact. 0.03. What is the ratio of the HFC emissions (in thousand metric tons of CO2 equivalent) in 2008 in Israel to that in Japan?
Your answer should be very brief. 0.03. What is the ratio of the HFC emissions (in thousand metric tons of CO2 equivalent) of 2000 in Israel to that in Korea (Democratic)?
Offer a very short reply. 0.39. What is the ratio of the HFC emissions (in thousand metric tons of CO2 equivalent) in 2005 in Israel to that in Korea (Democratic)?
Ensure brevity in your answer.  0.47. What is the ratio of the HFC emissions (in thousand metric tons of CO2 equivalent) in 2008 in Israel to that in Korea (Democratic)?
Your answer should be compact. 0.46. What is the ratio of the HFC emissions (in thousand metric tons of CO2 equivalent) of 1990 in Israel to that in Korea (Republic)?
Make the answer very short. 0. What is the ratio of the HFC emissions (in thousand metric tons of CO2 equivalent) of 2000 in Israel to that in Korea (Republic)?
Keep it short and to the point. 0.08. What is the ratio of the HFC emissions (in thousand metric tons of CO2 equivalent) in 2005 in Israel to that in Korea (Republic)?
Your answer should be very brief. 0.26. What is the ratio of the HFC emissions (in thousand metric tons of CO2 equivalent) of 2008 in Israel to that in Korea (Republic)?
Make the answer very short. 0.67. What is the ratio of the HFC emissions (in thousand metric tons of CO2 equivalent) in 1990 in Israel to that in Kuwait?
Offer a terse response. 46. What is the ratio of the HFC emissions (in thousand metric tons of CO2 equivalent) of 2000 in Israel to that in Kuwait?
Provide a short and direct response. 4.7. What is the ratio of the HFC emissions (in thousand metric tons of CO2 equivalent) in 2005 in Israel to that in Kuwait?
Keep it short and to the point. 2.42. What is the ratio of the HFC emissions (in thousand metric tons of CO2 equivalent) of 2008 in Israel to that in Kuwait?
Your answer should be compact. 2.17. What is the ratio of the HFC emissions (in thousand metric tons of CO2 equivalent) in 1990 in Italy to that in Japan?
Your answer should be compact. 0.22. What is the ratio of the HFC emissions (in thousand metric tons of CO2 equivalent) in 2000 in Italy to that in Japan?
Offer a terse response. 0.21. What is the ratio of the HFC emissions (in thousand metric tons of CO2 equivalent) of 2005 in Italy to that in Japan?
Offer a terse response. 0.22. What is the ratio of the HFC emissions (in thousand metric tons of CO2 equivalent) of 2008 in Italy to that in Japan?
Offer a terse response. 0.23. What is the ratio of the HFC emissions (in thousand metric tons of CO2 equivalent) in 1990 in Italy to that in Korea (Democratic)?
Provide a short and direct response. 9861. What is the ratio of the HFC emissions (in thousand metric tons of CO2 equivalent) in 2000 in Italy to that in Korea (Democratic)?
Offer a terse response. 4.03. What is the ratio of the HFC emissions (in thousand metric tons of CO2 equivalent) of 2005 in Italy to that in Korea (Democratic)?
Your answer should be compact. 3.27. What is the ratio of the HFC emissions (in thousand metric tons of CO2 equivalent) in 2008 in Italy to that in Korea (Democratic)?
Give a very brief answer. 3.23. What is the ratio of the HFC emissions (in thousand metric tons of CO2 equivalent) in 1990 in Italy to that in Korea (Republic)?
Ensure brevity in your answer.  1.04. What is the ratio of the HFC emissions (in thousand metric tons of CO2 equivalent) of 2000 in Italy to that in Korea (Republic)?
Ensure brevity in your answer.  0.85. What is the ratio of the HFC emissions (in thousand metric tons of CO2 equivalent) in 2005 in Italy to that in Korea (Republic)?
Provide a short and direct response. 1.85. What is the ratio of the HFC emissions (in thousand metric tons of CO2 equivalent) of 2008 in Italy to that in Korea (Republic)?
Provide a short and direct response. 4.75. What is the ratio of the HFC emissions (in thousand metric tons of CO2 equivalent) of 1990 in Italy to that in Kuwait?
Provide a short and direct response. 1.97e+04. What is the ratio of the HFC emissions (in thousand metric tons of CO2 equivalent) of 2000 in Italy to that in Kuwait?
Keep it short and to the point. 48.2. What is the ratio of the HFC emissions (in thousand metric tons of CO2 equivalent) of 2005 in Italy to that in Kuwait?
Offer a terse response. 16.89. What is the ratio of the HFC emissions (in thousand metric tons of CO2 equivalent) in 2008 in Italy to that in Kuwait?
Give a very brief answer. 15.31. What is the ratio of the HFC emissions (in thousand metric tons of CO2 equivalent) of 1990 in Japan to that in Korea (Democratic)?
Your answer should be very brief. 4.58e+04. What is the ratio of the HFC emissions (in thousand metric tons of CO2 equivalent) of 2000 in Japan to that in Korea (Democratic)?
Your answer should be compact. 19.4. What is the ratio of the HFC emissions (in thousand metric tons of CO2 equivalent) of 2005 in Japan to that in Korea (Democratic)?
Make the answer very short. 14.63. What is the ratio of the HFC emissions (in thousand metric tons of CO2 equivalent) of 2008 in Japan to that in Korea (Democratic)?
Give a very brief answer. 14.31. What is the ratio of the HFC emissions (in thousand metric tons of CO2 equivalent) of 1990 in Japan to that in Korea (Republic)?
Offer a very short reply. 4.81. What is the ratio of the HFC emissions (in thousand metric tons of CO2 equivalent) in 2000 in Japan to that in Korea (Republic)?
Your response must be concise. 4.08. What is the ratio of the HFC emissions (in thousand metric tons of CO2 equivalent) in 2005 in Japan to that in Korea (Republic)?
Offer a terse response. 8.26. What is the ratio of the HFC emissions (in thousand metric tons of CO2 equivalent) of 2008 in Japan to that in Korea (Republic)?
Give a very brief answer. 21.05. What is the ratio of the HFC emissions (in thousand metric tons of CO2 equivalent) in 1990 in Japan to that in Kuwait?
Your answer should be compact. 9.15e+04. What is the ratio of the HFC emissions (in thousand metric tons of CO2 equivalent) in 2000 in Japan to that in Kuwait?
Provide a succinct answer. 231.77. What is the ratio of the HFC emissions (in thousand metric tons of CO2 equivalent) in 2005 in Japan to that in Kuwait?
Offer a very short reply. 75.55. What is the ratio of the HFC emissions (in thousand metric tons of CO2 equivalent) in 2008 in Japan to that in Kuwait?
Offer a terse response. 67.87. What is the ratio of the HFC emissions (in thousand metric tons of CO2 equivalent) of 2000 in Korea (Democratic) to that in Korea (Republic)?
Offer a terse response. 0.21. What is the ratio of the HFC emissions (in thousand metric tons of CO2 equivalent) of 2005 in Korea (Democratic) to that in Korea (Republic)?
Your answer should be very brief. 0.56. What is the ratio of the HFC emissions (in thousand metric tons of CO2 equivalent) in 2008 in Korea (Democratic) to that in Korea (Republic)?
Provide a short and direct response. 1.47. What is the ratio of the HFC emissions (in thousand metric tons of CO2 equivalent) in 1990 in Korea (Democratic) to that in Kuwait?
Provide a succinct answer. 2. What is the ratio of the HFC emissions (in thousand metric tons of CO2 equivalent) in 2000 in Korea (Democratic) to that in Kuwait?
Ensure brevity in your answer.  11.95. What is the ratio of the HFC emissions (in thousand metric tons of CO2 equivalent) in 2005 in Korea (Democratic) to that in Kuwait?
Make the answer very short. 5.17. What is the ratio of the HFC emissions (in thousand metric tons of CO2 equivalent) of 2008 in Korea (Democratic) to that in Kuwait?
Offer a terse response. 4.74. What is the ratio of the HFC emissions (in thousand metric tons of CO2 equivalent) of 1990 in Korea (Republic) to that in Kuwait?
Offer a very short reply. 1.90e+04. What is the ratio of the HFC emissions (in thousand metric tons of CO2 equivalent) in 2000 in Korea (Republic) to that in Kuwait?
Your answer should be very brief. 56.84. What is the ratio of the HFC emissions (in thousand metric tons of CO2 equivalent) of 2005 in Korea (Republic) to that in Kuwait?
Keep it short and to the point. 9.14. What is the ratio of the HFC emissions (in thousand metric tons of CO2 equivalent) of 2008 in Korea (Republic) to that in Kuwait?
Keep it short and to the point. 3.22. What is the difference between the highest and the second highest HFC emissions (in thousand metric tons of CO2 equivalent) of 1990?
Provide a succinct answer. 7182.1. What is the difference between the highest and the second highest HFC emissions (in thousand metric tons of CO2 equivalent) of 2000?
Offer a very short reply. 2.58e+04. What is the difference between the highest and the second highest HFC emissions (in thousand metric tons of CO2 equivalent) in 2005?
Provide a short and direct response. 3.17e+04. What is the difference between the highest and the second highest HFC emissions (in thousand metric tons of CO2 equivalent) in 2008?
Provide a short and direct response. 4.09e+04. What is the difference between the highest and the lowest HFC emissions (in thousand metric tons of CO2 equivalent) in 1990?
Give a very brief answer. 9154.2. What is the difference between the highest and the lowest HFC emissions (in thousand metric tons of CO2 equivalent) in 2000?
Your answer should be compact. 3.40e+04. What is the difference between the highest and the lowest HFC emissions (in thousand metric tons of CO2 equivalent) in 2005?
Your answer should be very brief. 4.02e+04. What is the difference between the highest and the lowest HFC emissions (in thousand metric tons of CO2 equivalent) of 2008?
Provide a short and direct response. 5.21e+04. 